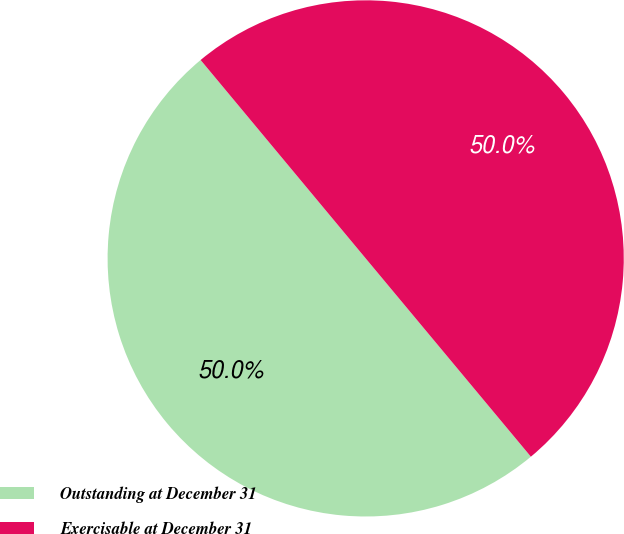Convert chart to OTSL. <chart><loc_0><loc_0><loc_500><loc_500><pie_chart><fcel>Outstanding at December 31<fcel>Exercisable at December 31<nl><fcel>50.01%<fcel>49.99%<nl></chart> 